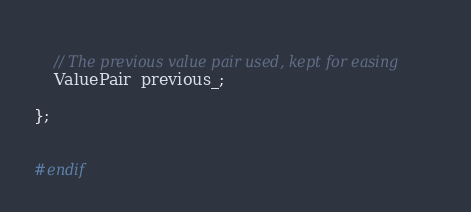Convert code to text. <code><loc_0><loc_0><loc_500><loc_500><_C_>    
    // The previous value pair used, kept for easing
    ValuePair  previous_;
    
};


#endif
</code> 